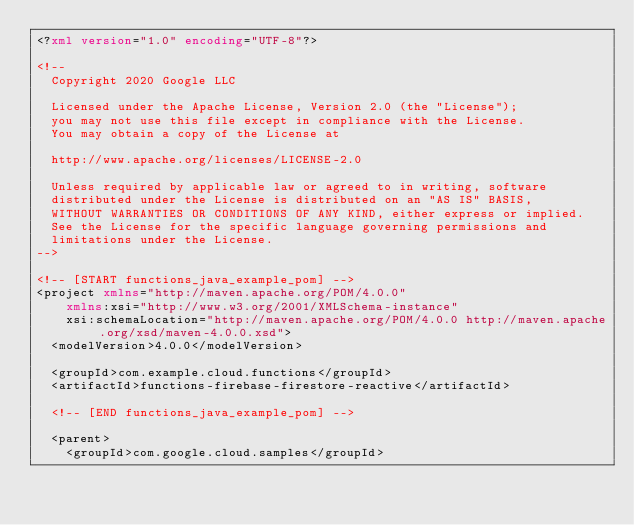Convert code to text. <code><loc_0><loc_0><loc_500><loc_500><_XML_><?xml version="1.0" encoding="UTF-8"?>

<!--
  Copyright 2020 Google LLC

  Licensed under the Apache License, Version 2.0 (the "License");
  you may not use this file except in compliance with the License.
  You may obtain a copy of the License at

  http://www.apache.org/licenses/LICENSE-2.0

  Unless required by applicable law or agreed to in writing, software
  distributed under the License is distributed on an "AS IS" BASIS,
  WITHOUT WARRANTIES OR CONDITIONS OF ANY KIND, either express or implied.
  See the License for the specific language governing permissions and
  limitations under the License.
-->

<!-- [START functions_java_example_pom] -->
<project xmlns="http://maven.apache.org/POM/4.0.0"
    xmlns:xsi="http://www.w3.org/2001/XMLSchema-instance"
    xsi:schemaLocation="http://maven.apache.org/POM/4.0.0 http://maven.apache.org/xsd/maven-4.0.0.xsd">
  <modelVersion>4.0.0</modelVersion>

  <groupId>com.example.cloud.functions</groupId>
  <artifactId>functions-firebase-firestore-reactive</artifactId>
  
  <!-- [END functions_java_example_pom] -->

  <parent>
    <groupId>com.google.cloud.samples</groupId></code> 